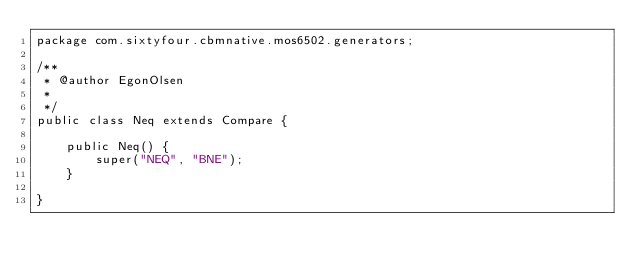<code> <loc_0><loc_0><loc_500><loc_500><_Java_>package com.sixtyfour.cbmnative.mos6502.generators;

/**
 * @author EgonOlsen
 * 
 */
public class Neq extends Compare {

	public Neq() {
		super("NEQ", "BNE");
	}

}
</code> 